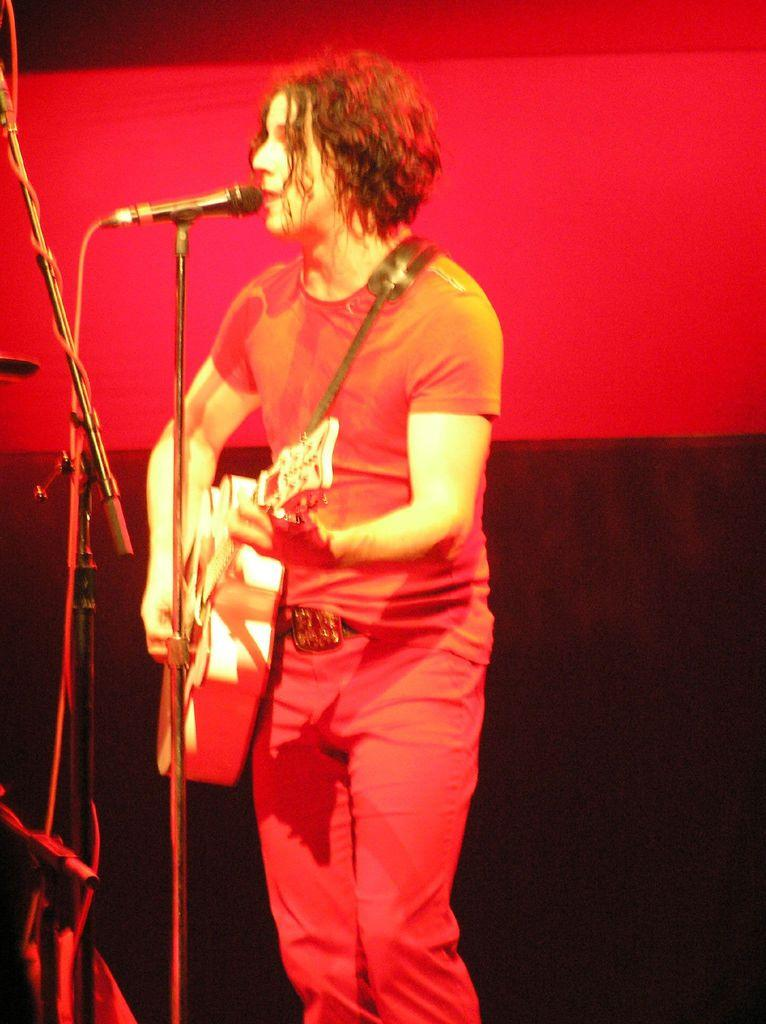Who is the main subject in the image? There is a man in the image. What is the man doing in the image? The man is singing a song and playing a guitar. What object is the man standing near? The man is standing near a microphone. What can be seen in the background of the image? There is a red color curtain in the background. Can you tell me how many needles are visible in the image? There are no needles present in the image. What type of card is the man holding in the image? There is no card present in the image; the man is holding a guitar. 